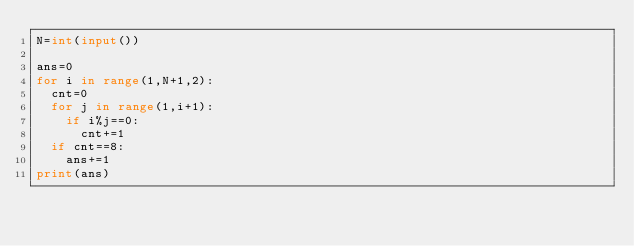Convert code to text. <code><loc_0><loc_0><loc_500><loc_500><_Python_>N=int(input())

ans=0
for i in range(1,N+1,2):
  cnt=0
  for j in range(1,i+1):
    if i%j==0:
      cnt+=1
  if cnt==8:
    ans+=1
print(ans)  </code> 